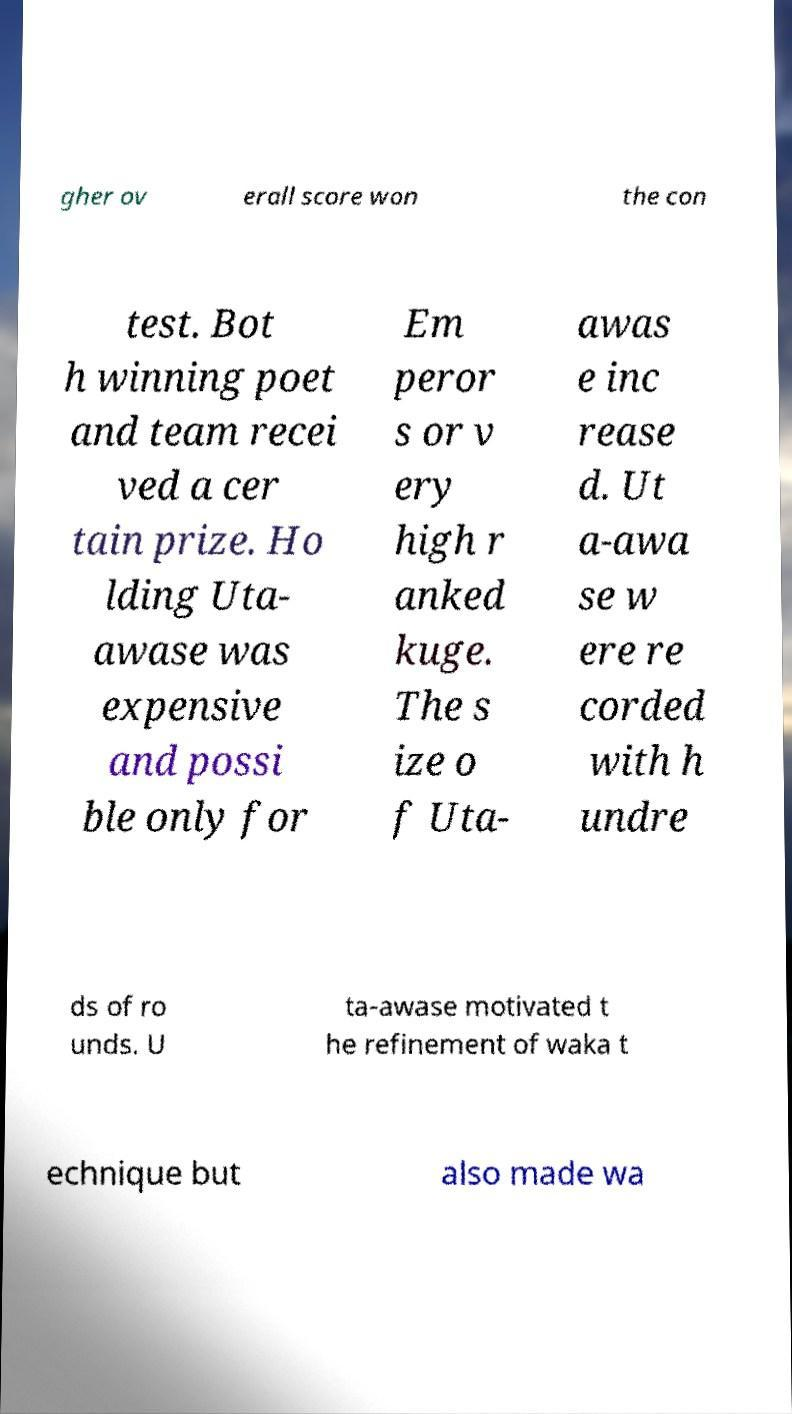For documentation purposes, I need the text within this image transcribed. Could you provide that? gher ov erall score won the con test. Bot h winning poet and team recei ved a cer tain prize. Ho lding Uta- awase was expensive and possi ble only for Em peror s or v ery high r anked kuge. The s ize o f Uta- awas e inc rease d. Ut a-awa se w ere re corded with h undre ds of ro unds. U ta-awase motivated t he refinement of waka t echnique but also made wa 